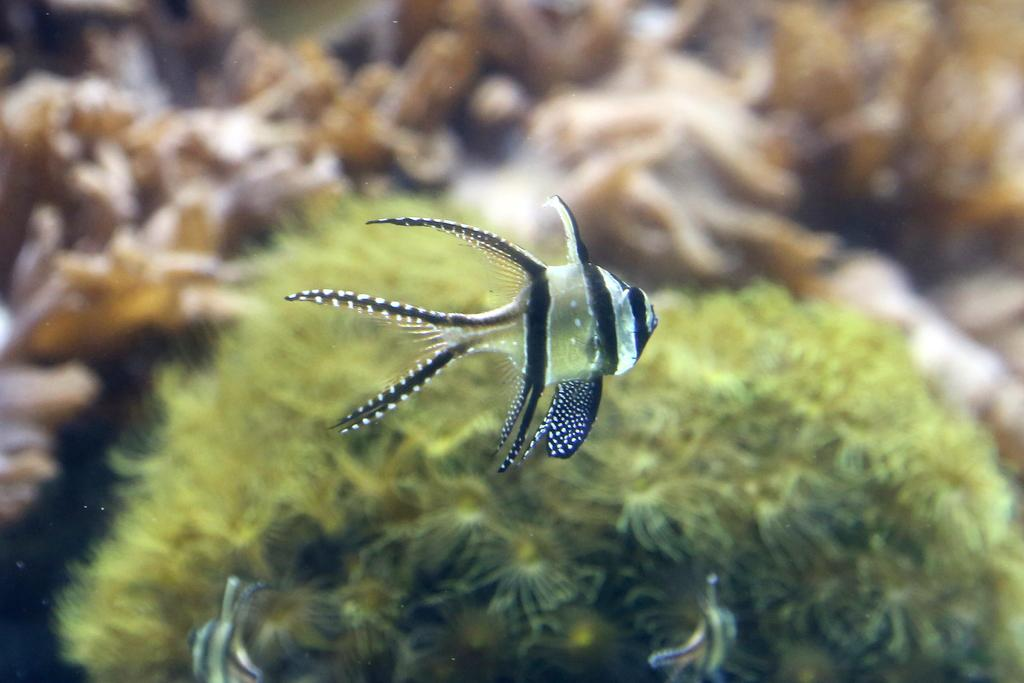What type of animals can be seen in the water in the image? There are fish in the water in the image. What can be seen behind the fish in the image? There are plants visible behind the fish in the image. What type of gun is being used to catch the fish in the image? There is no gun present in the image; the fish are in the water and not being caught. 